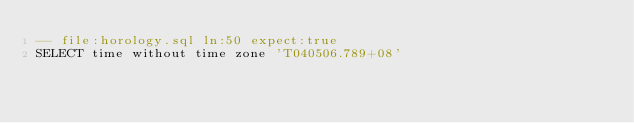<code> <loc_0><loc_0><loc_500><loc_500><_SQL_>-- file:horology.sql ln:50 expect:true
SELECT time without time zone 'T040506.789+08'
</code> 